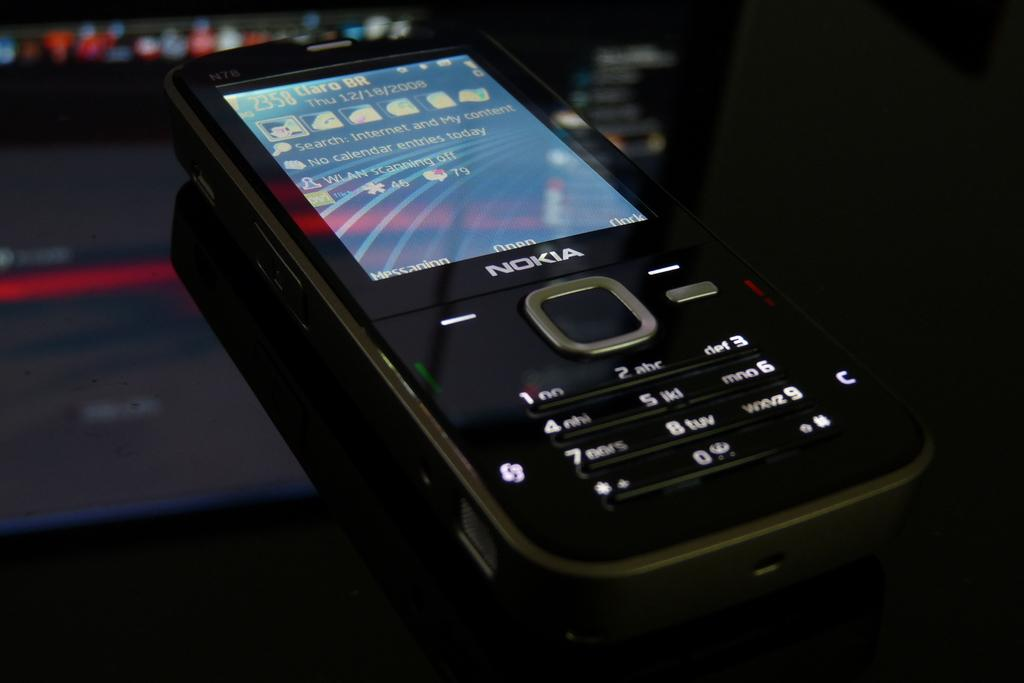Provide a one-sentence caption for the provided image. an old NOKIA phone in black with a lit up display. 